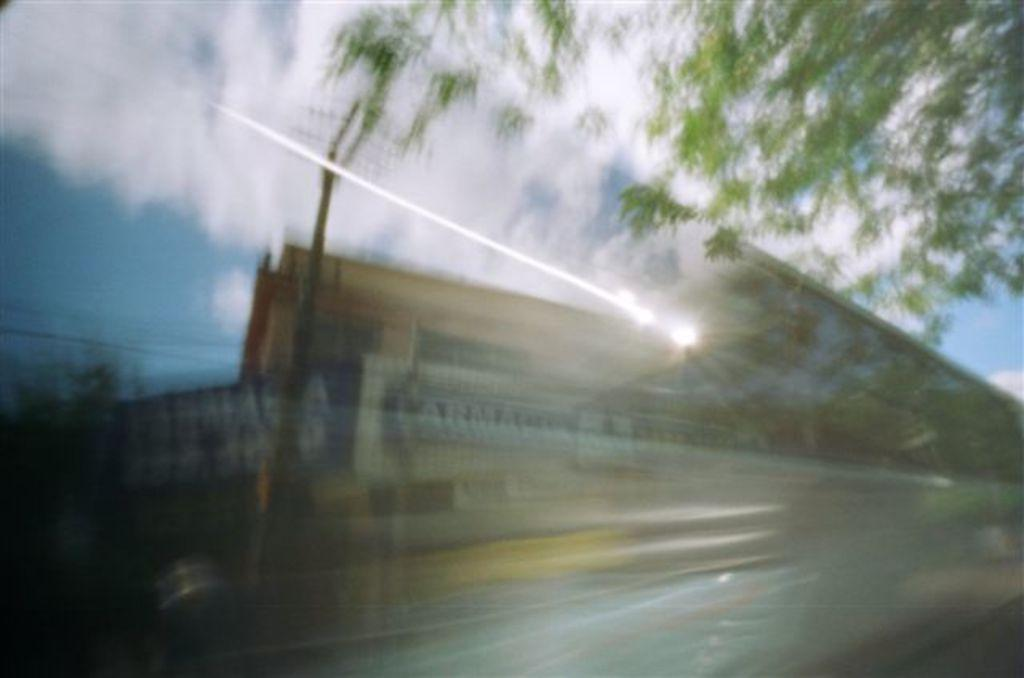What type of vegetation can be seen in the image? There are trees in the image. What is the color of the trees? The trees are green in color. What is visible in the background of the image? The sky is visible in the background of the image. What colors can be seen in the sky? The sky is blue and white in color. How is the image of the sky depicted? The image of the sky appears blurred. What type of grape is being produced by the trees in the image? There are no grapes or grape production mentioned in the image; the trees are simply green in color. 